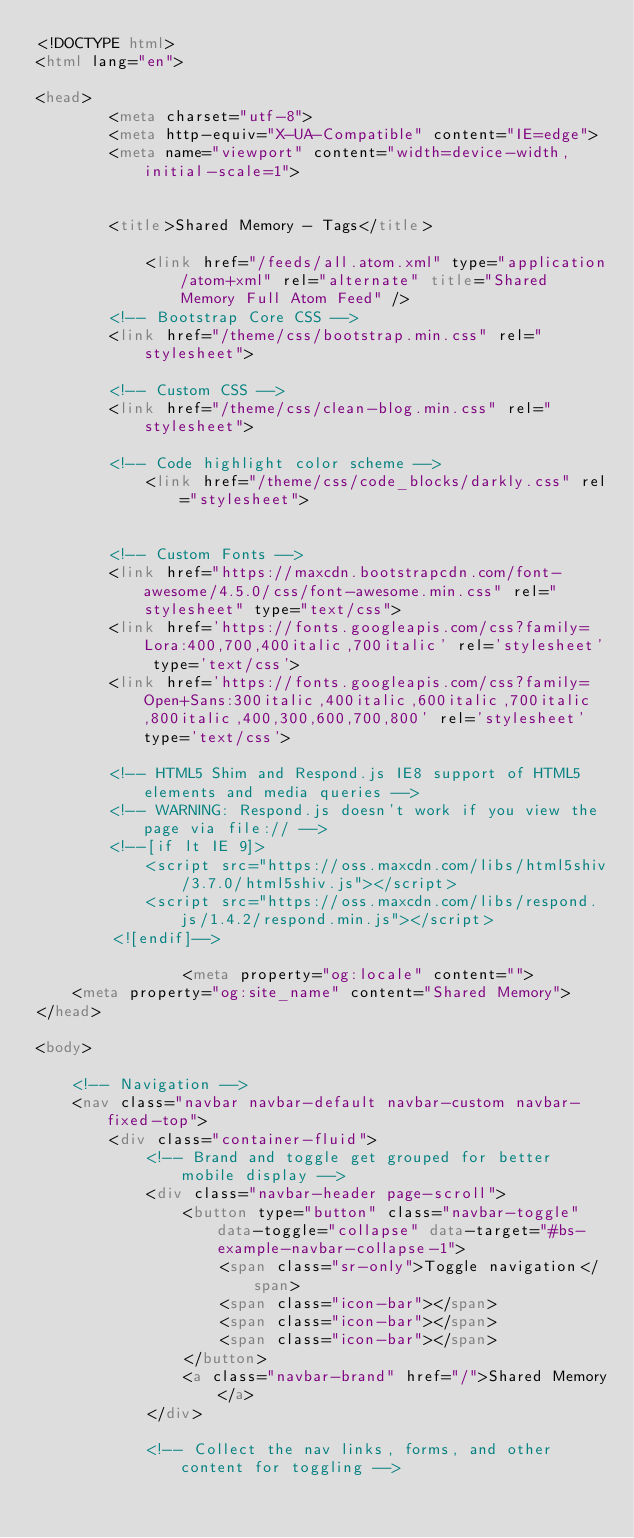<code> <loc_0><loc_0><loc_500><loc_500><_HTML_><!DOCTYPE html>
<html lang="en">

<head>
        <meta charset="utf-8">
        <meta http-equiv="X-UA-Compatible" content="IE=edge">
        <meta name="viewport" content="width=device-width, initial-scale=1">


        <title>Shared Memory - Tags</title>

            <link href="/feeds/all.atom.xml" type="application/atom+xml" rel="alternate" title="Shared Memory Full Atom Feed" />
        <!-- Bootstrap Core CSS -->
        <link href="/theme/css/bootstrap.min.css" rel="stylesheet">

        <!-- Custom CSS -->
        <link href="/theme/css/clean-blog.min.css" rel="stylesheet">

        <!-- Code highlight color scheme -->
            <link href="/theme/css/code_blocks/darkly.css" rel="stylesheet">


        <!-- Custom Fonts -->
        <link href="https://maxcdn.bootstrapcdn.com/font-awesome/4.5.0/css/font-awesome.min.css" rel="stylesheet" type="text/css">
        <link href='https://fonts.googleapis.com/css?family=Lora:400,700,400italic,700italic' rel='stylesheet' type='text/css'>
        <link href='https://fonts.googleapis.com/css?family=Open+Sans:300italic,400italic,600italic,700italic,800italic,400,300,600,700,800' rel='stylesheet' type='text/css'>

        <!-- HTML5 Shim and Respond.js IE8 support of HTML5 elements and media queries -->
        <!-- WARNING: Respond.js doesn't work if you view the page via file:// -->
        <!--[if lt IE 9]>
            <script src="https://oss.maxcdn.com/libs/html5shiv/3.7.0/html5shiv.js"></script>
            <script src="https://oss.maxcdn.com/libs/respond.js/1.4.2/respond.min.js"></script>
        <![endif]-->

                <meta property="og:locale" content="">
		<meta property="og:site_name" content="Shared Memory">
</head>

<body>

    <!-- Navigation -->
    <nav class="navbar navbar-default navbar-custom navbar-fixed-top">
        <div class="container-fluid">
            <!-- Brand and toggle get grouped for better mobile display -->
            <div class="navbar-header page-scroll">
                <button type="button" class="navbar-toggle" data-toggle="collapse" data-target="#bs-example-navbar-collapse-1">
                    <span class="sr-only">Toggle navigation</span>
                    <span class="icon-bar"></span>
                    <span class="icon-bar"></span>
                    <span class="icon-bar"></span>
                </button>
                <a class="navbar-brand" href="/">Shared Memory</a>
            </div>

            <!-- Collect the nav links, forms, and other content for toggling --></code> 